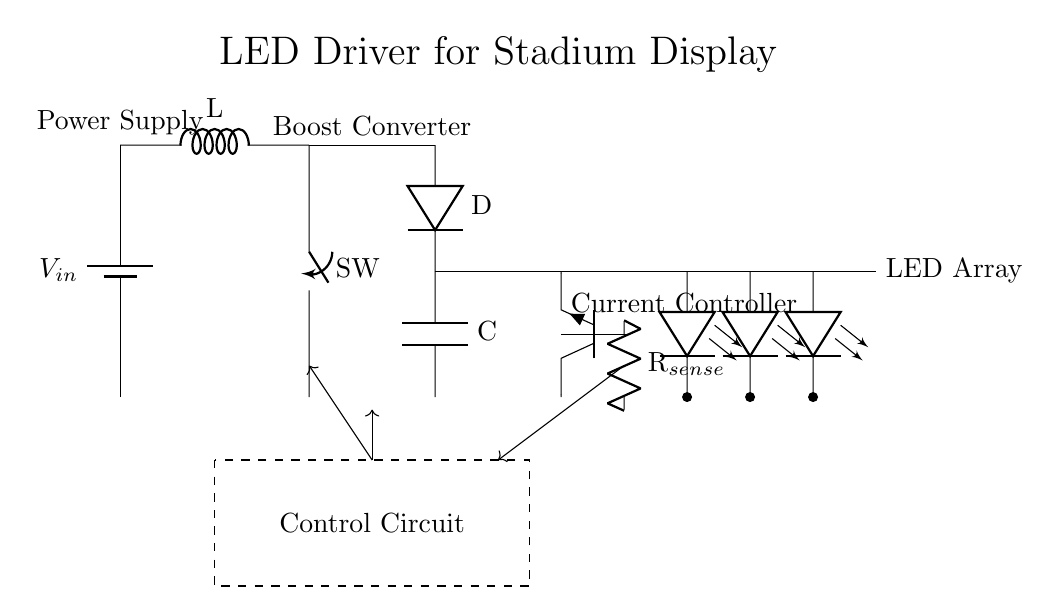What is the input voltage to the circuit? The input voltage is denoted as V_in, which is represented by the battery symbol in the diagram.
Answer: V_in What component limits the current to the LED array? The component that limits the current is the resistor labeled R_sense, which is connected in series with the LEDs, allowing the current to be monitored and controlled.
Answer: R_sense What is the purpose of the boost converter in the circuit? The boost converter steps up the voltage from the input voltage to a higher level suitable for the LED array, which requires a higher voltage to operate effectively.
Answer: Voltage stepping How many LED components are there in the array? There are three LED components shown in the circuit, as indicated by the three separate LED symbols connected in parallel.
Answer: Three What type of transistor is used in the current controller? The current controller uses a bipolar junction transistor, specifically a Tnpn transistor, which is indicated by the symbol that represents this type of transistor in the circuit diagram.
Answer: Tnpn What does the dashed rectangle in the circuit signify? The dashed rectangle indicates the control circuit area, which contains the components responsible for regulating and managing the overall circuit operation, such as feedback mechanisms and control signals.
Answer: Control circuit 